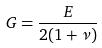Convert formula to latex. <formula><loc_0><loc_0><loc_500><loc_500>G = \frac { E } { 2 ( 1 + \nu ) }</formula> 